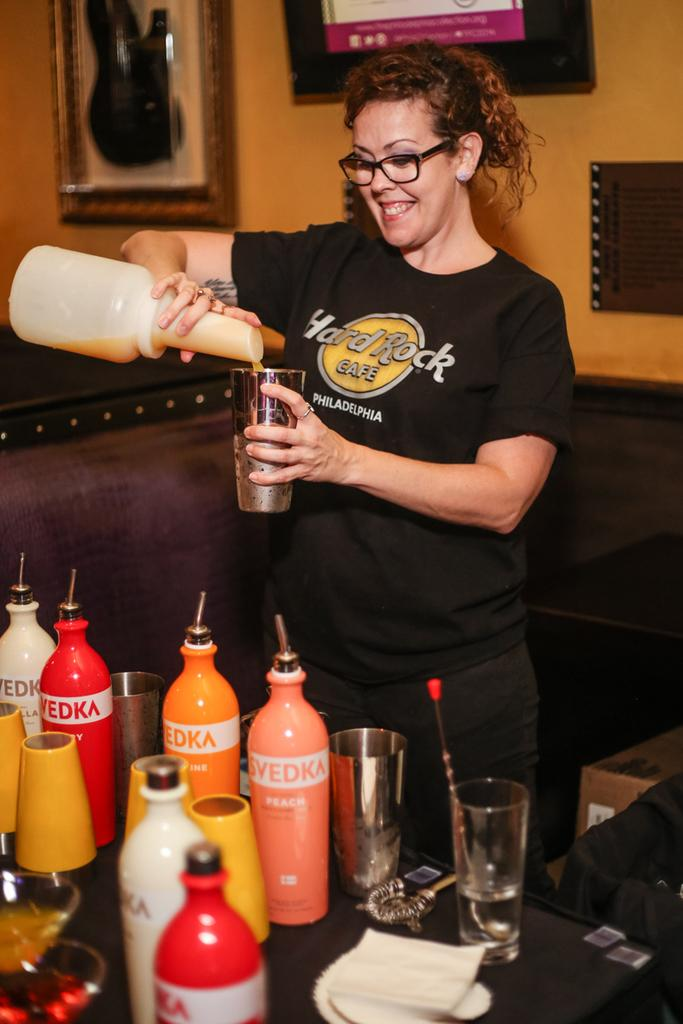<image>
Present a compact description of the photo's key features. a girl mixing drings wearing a hard rock cafe tshirt 